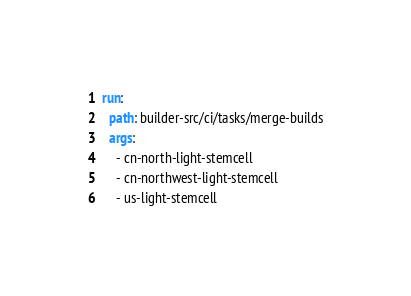<code> <loc_0><loc_0><loc_500><loc_500><_YAML_>
run:
  path: builder-src/ci/tasks/merge-builds
  args:
    - cn-north-light-stemcell
    - cn-northwest-light-stemcell
    - us-light-stemcell
</code> 